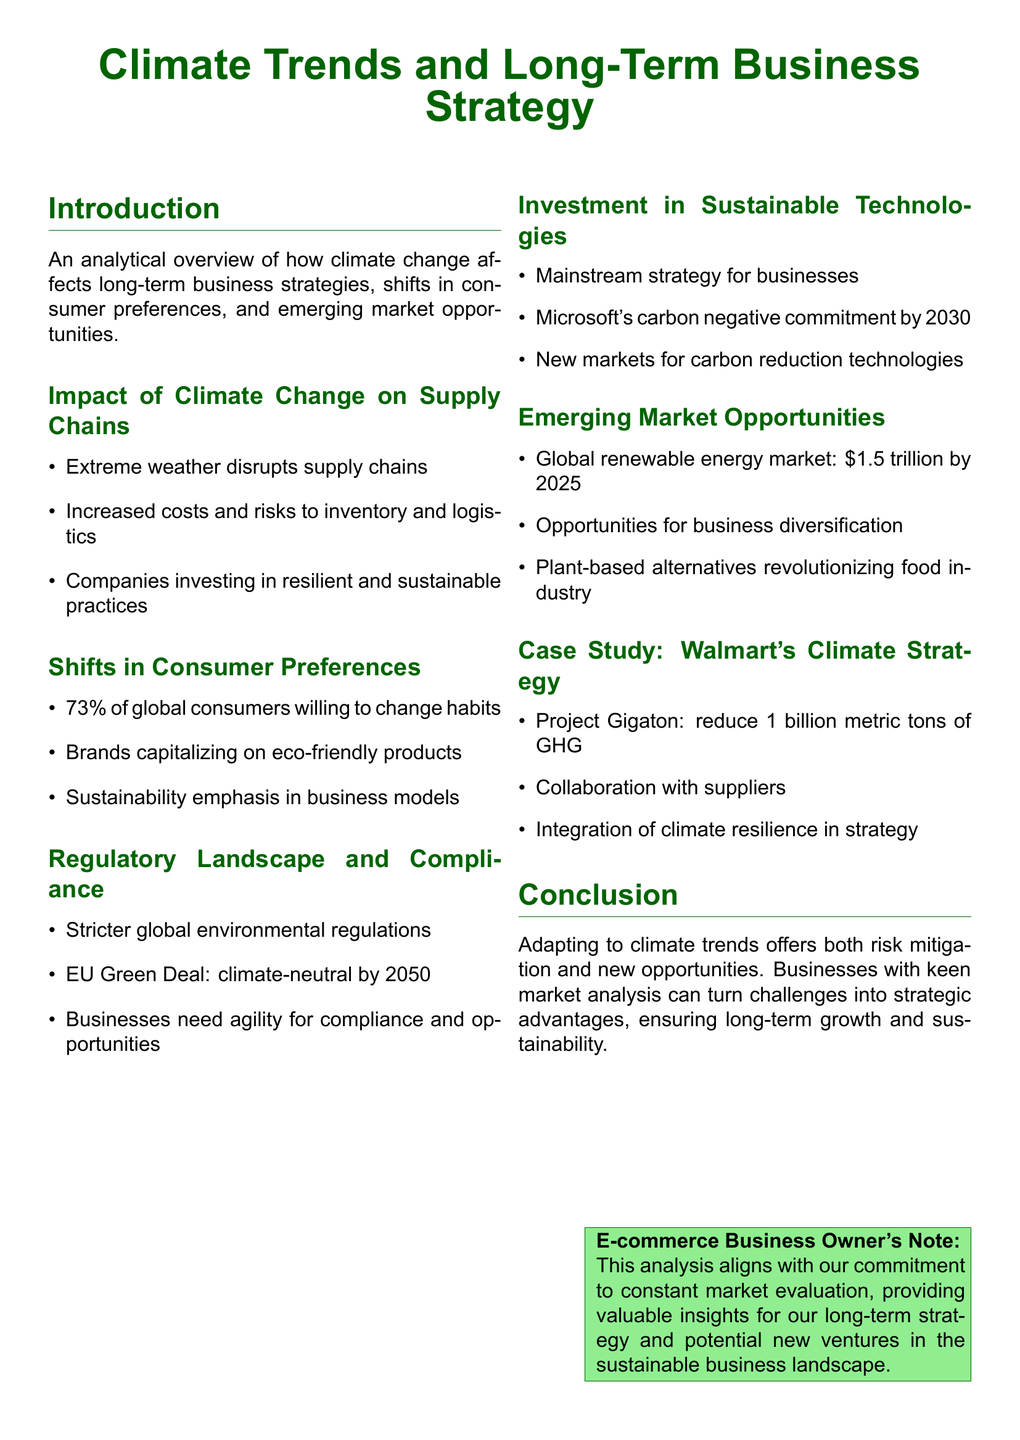What is the global renewable energy market value by 2025? The document states that the global renewable energy market is projected to be worth $1.5 trillion by 2025.
Answer: $1.5 trillion What percentage of global consumers are willing to change habits? According to the document, 73% of global consumers are willing to change their habits.
Answer: 73% What is Microsoft's commitment regarding carbon emissions? The document mentions that Microsoft has a commitment to being carbon negative by 2030.
Answer: carbon negative by 2030 What is the name of Walmart's climate strategy? The document refers to Walmart's climate strategy as Project Gigaton.
Answer: Project Gigaton What is a significant impact of extreme weather on businesses? The document states that extreme weather disrupts supply chains, which is a significant impact.
Answer: disrupts supply chains What type of products are brands capitalizing on according to the document? The document indicates that brands are capitalizing on eco-friendly products.
Answer: eco-friendly products What is one of the opportunities presented by climate trends for businesses? The document mentions that there are opportunities for business diversification due to climate trends.
Answer: business diversification What regulatory initiative is mentioned in relation to climate compliance? The document discusses the EU Green Deal, which aims for climate neutrality by 2050.
Answer: EU Green Deal What is the focus of investment for businesses mentioned in the document? According to the document, businesses are focusing their investments on sustainable technologies.
Answer: sustainable technologies 